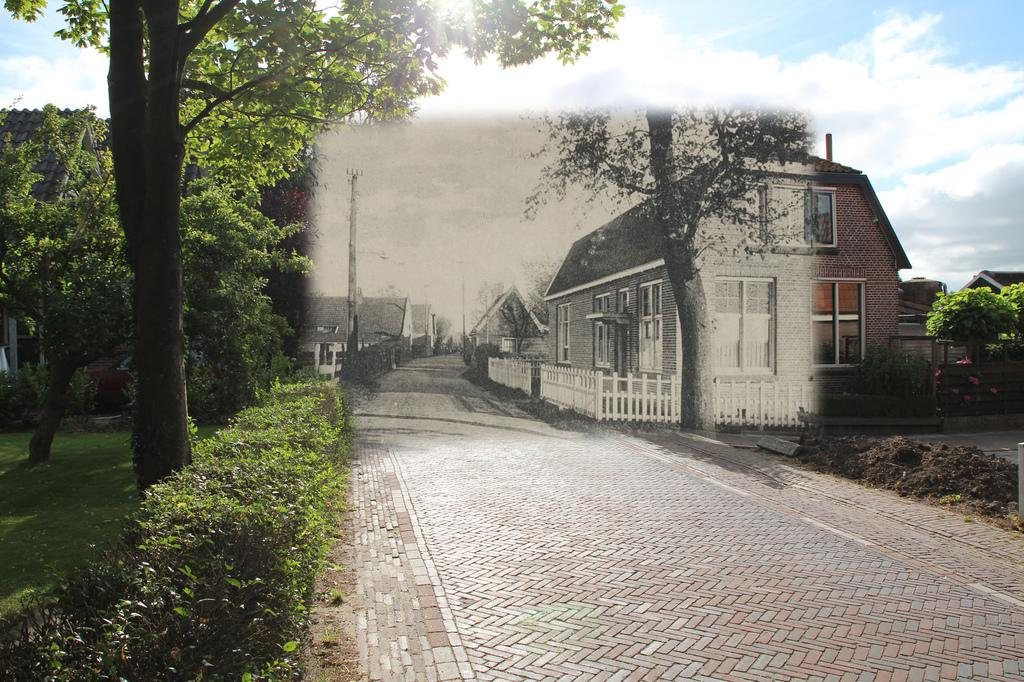What is the main feature of the image? There is a road in the image. What can be seen on the left side of the image? There are plants and trees on the left side of the image. What is visible in the background of the image? There are houses and the sky visible in the background of the image. How many secretaries are visible in the image? There are no secretaries present in the image. What type of pain is being experienced by the trees in the image? There is no indication of pain being experienced by the trees in the image. 